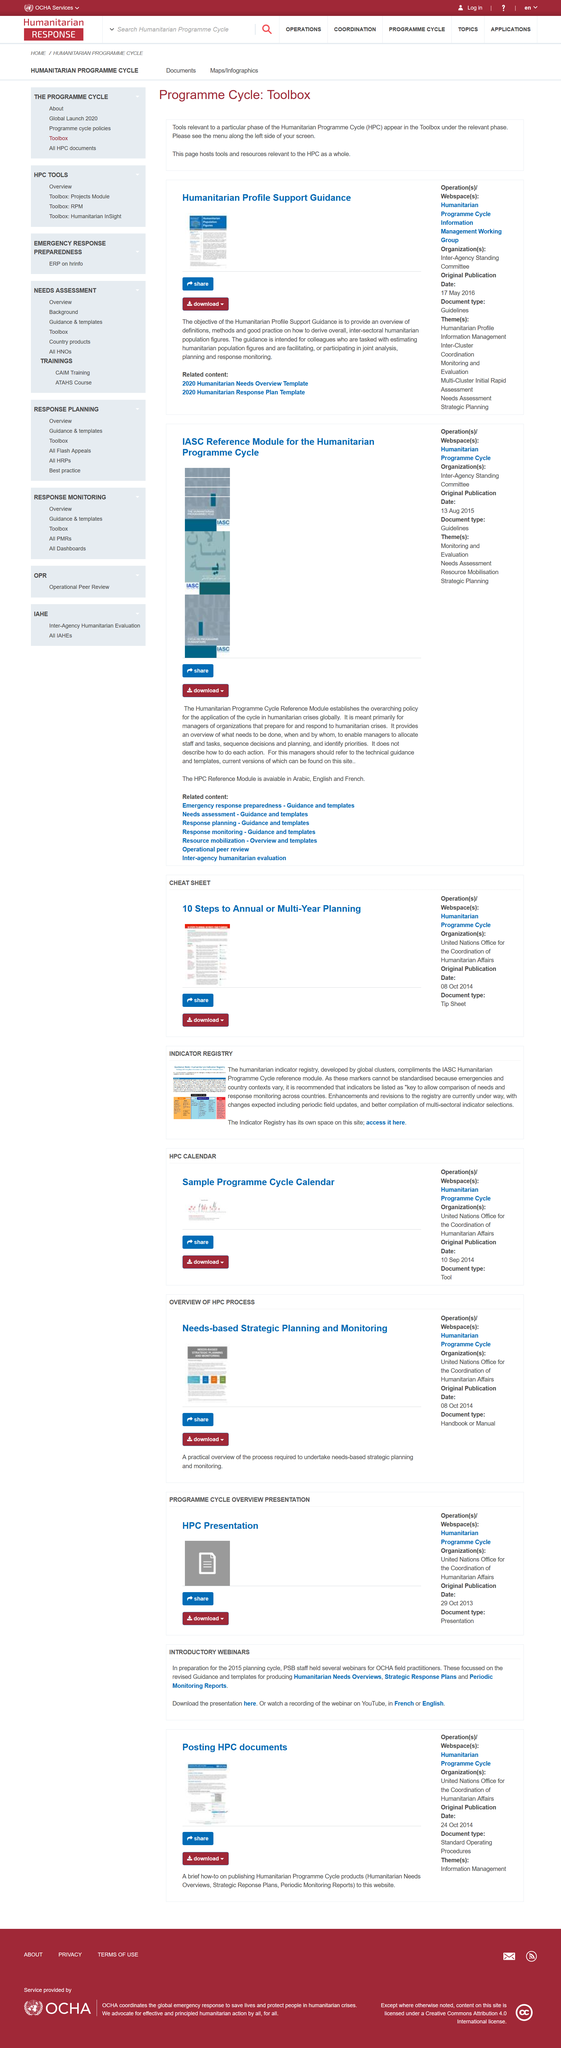Draw attention to some important aspects in this diagram. The HPC Reference module is available in three languages. The total number of pages containing related content is 7. The Humanitarian Programme Cycle Reference Module (HPCRM) is a comprehensive guide that provides a framework for effective humanitarian response. 